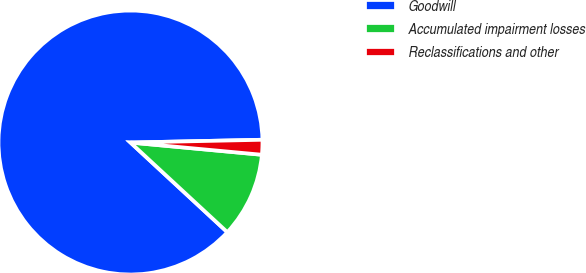Convert chart. <chart><loc_0><loc_0><loc_500><loc_500><pie_chart><fcel>Goodwill<fcel>Accumulated impairment losses<fcel>Reclassifications and other<nl><fcel>87.78%<fcel>10.41%<fcel>1.81%<nl></chart> 